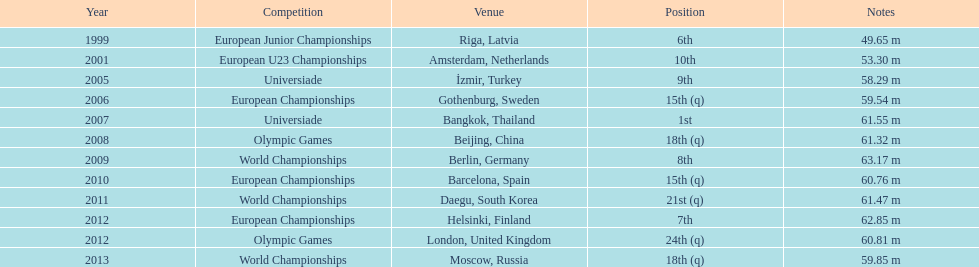What are the total number of times european junior championships is listed as the competition? 1. 